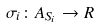Convert formula to latex. <formula><loc_0><loc_0><loc_500><loc_500>\sigma _ { i } \colon A _ { S _ { i } } \rightarrow R</formula> 